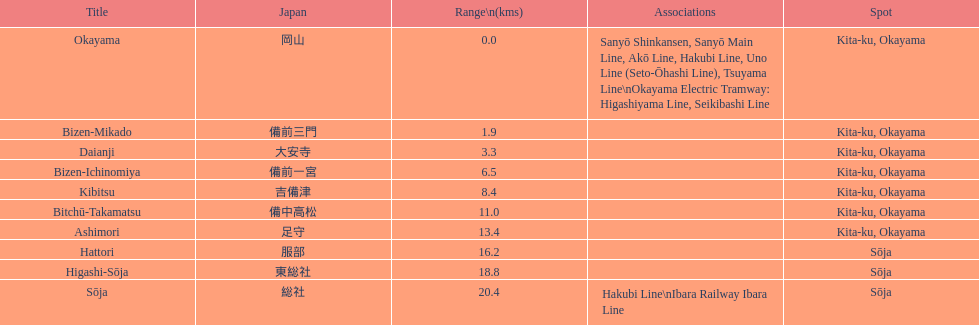Could you help me parse every detail presented in this table? {'header': ['Title', 'Japan', 'Range\\n(kms)', 'Associations', 'Spot'], 'rows': [['Okayama', '岡山', '0.0', 'Sanyō Shinkansen, Sanyō Main Line, Akō Line, Hakubi Line, Uno Line (Seto-Ōhashi Line), Tsuyama Line\\nOkayama Electric Tramway: Higashiyama Line, Seikibashi Line', 'Kita-ku, Okayama'], ['Bizen-Mikado', '備前三門', '1.9', '', 'Kita-ku, Okayama'], ['Daianji', '大安寺', '3.3', '', 'Kita-ku, Okayama'], ['Bizen-Ichinomiya', '備前一宮', '6.5', '', 'Kita-ku, Okayama'], ['Kibitsu', '吉備津', '8.4', '', 'Kita-ku, Okayama'], ['Bitchū-Takamatsu', '備中高松', '11.0', '', 'Kita-ku, Okayama'], ['Ashimori', '足守', '13.4', '', 'Kita-ku, Okayama'], ['Hattori', '服部', '16.2', '', 'Sōja'], ['Higashi-Sōja', '東総社', '18.8', '', 'Sōja'], ['Sōja', '総社', '20.4', 'Hakubi Line\\nIbara Railway Ibara Line', 'Sōja']]} How many stations have a distance below 15km? 7. 